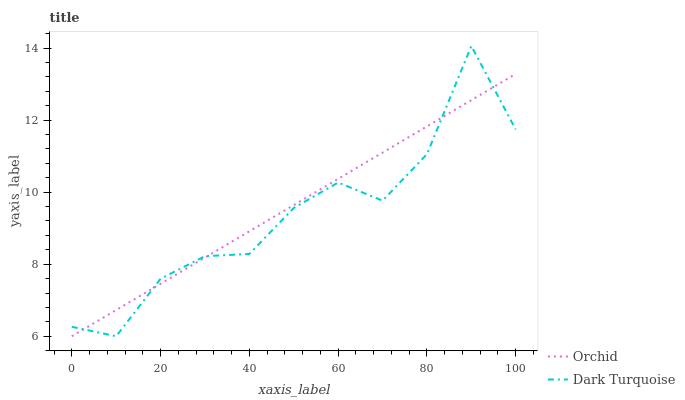Does Dark Turquoise have the minimum area under the curve?
Answer yes or no. Yes. Does Orchid have the maximum area under the curve?
Answer yes or no. Yes. Does Orchid have the minimum area under the curve?
Answer yes or no. No. Is Orchid the smoothest?
Answer yes or no. Yes. Is Dark Turquoise the roughest?
Answer yes or no. Yes. Is Orchid the roughest?
Answer yes or no. No. Does Dark Turquoise have the highest value?
Answer yes or no. Yes. Does Orchid have the highest value?
Answer yes or no. No. Does Dark Turquoise intersect Orchid?
Answer yes or no. Yes. Is Dark Turquoise less than Orchid?
Answer yes or no. No. Is Dark Turquoise greater than Orchid?
Answer yes or no. No. 